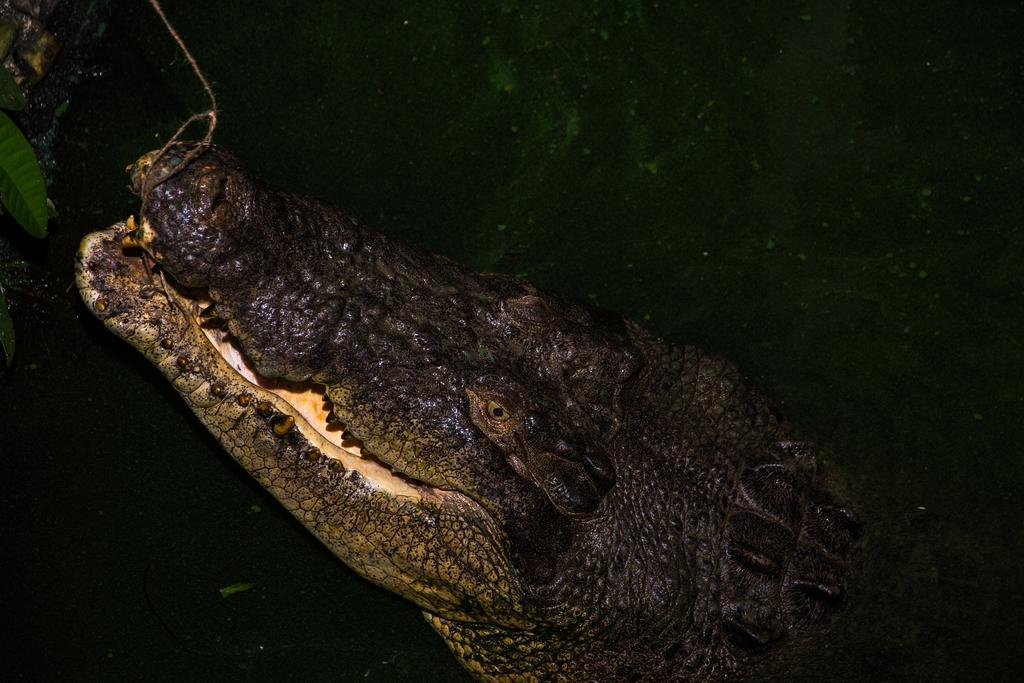What animal is present in the image? There is a crocodile in the image. What type of vegetation can be seen in the image? There are leaves in the image. What is the color of the background in the image? The background of the image is dark. What type of hospital can be seen in the image? There is no hospital present in the image; it features a crocodile and leaves. What type of beast is depicted in the image? The image does not depict a beast; it features a crocodile, which is a reptile. 